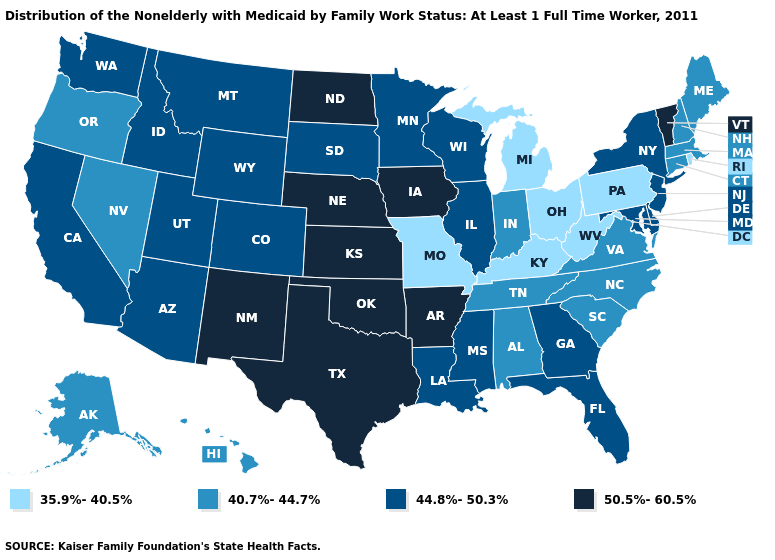Does New Mexico have the highest value in the USA?
Give a very brief answer. Yes. What is the highest value in the USA?
Short answer required. 50.5%-60.5%. Which states hav the highest value in the South?
Quick response, please. Arkansas, Oklahoma, Texas. Among the states that border New York , which have the lowest value?
Answer briefly. Pennsylvania. What is the value of Maryland?
Answer briefly. 44.8%-50.3%. Does South Dakota have the same value as Washington?
Give a very brief answer. Yes. Which states have the lowest value in the West?
Give a very brief answer. Alaska, Hawaii, Nevada, Oregon. What is the lowest value in states that border Texas?
Short answer required. 44.8%-50.3%. Does Maine have a lower value than Kentucky?
Write a very short answer. No. Name the states that have a value in the range 44.8%-50.3%?
Short answer required. Arizona, California, Colorado, Delaware, Florida, Georgia, Idaho, Illinois, Louisiana, Maryland, Minnesota, Mississippi, Montana, New Jersey, New York, South Dakota, Utah, Washington, Wisconsin, Wyoming. What is the value of Texas?
Quick response, please. 50.5%-60.5%. Among the states that border Iowa , which have the lowest value?
Be succinct. Missouri. What is the lowest value in the MidWest?
Be succinct. 35.9%-40.5%. Name the states that have a value in the range 44.8%-50.3%?
Answer briefly. Arizona, California, Colorado, Delaware, Florida, Georgia, Idaho, Illinois, Louisiana, Maryland, Minnesota, Mississippi, Montana, New Jersey, New York, South Dakota, Utah, Washington, Wisconsin, Wyoming. What is the lowest value in the USA?
Answer briefly. 35.9%-40.5%. 